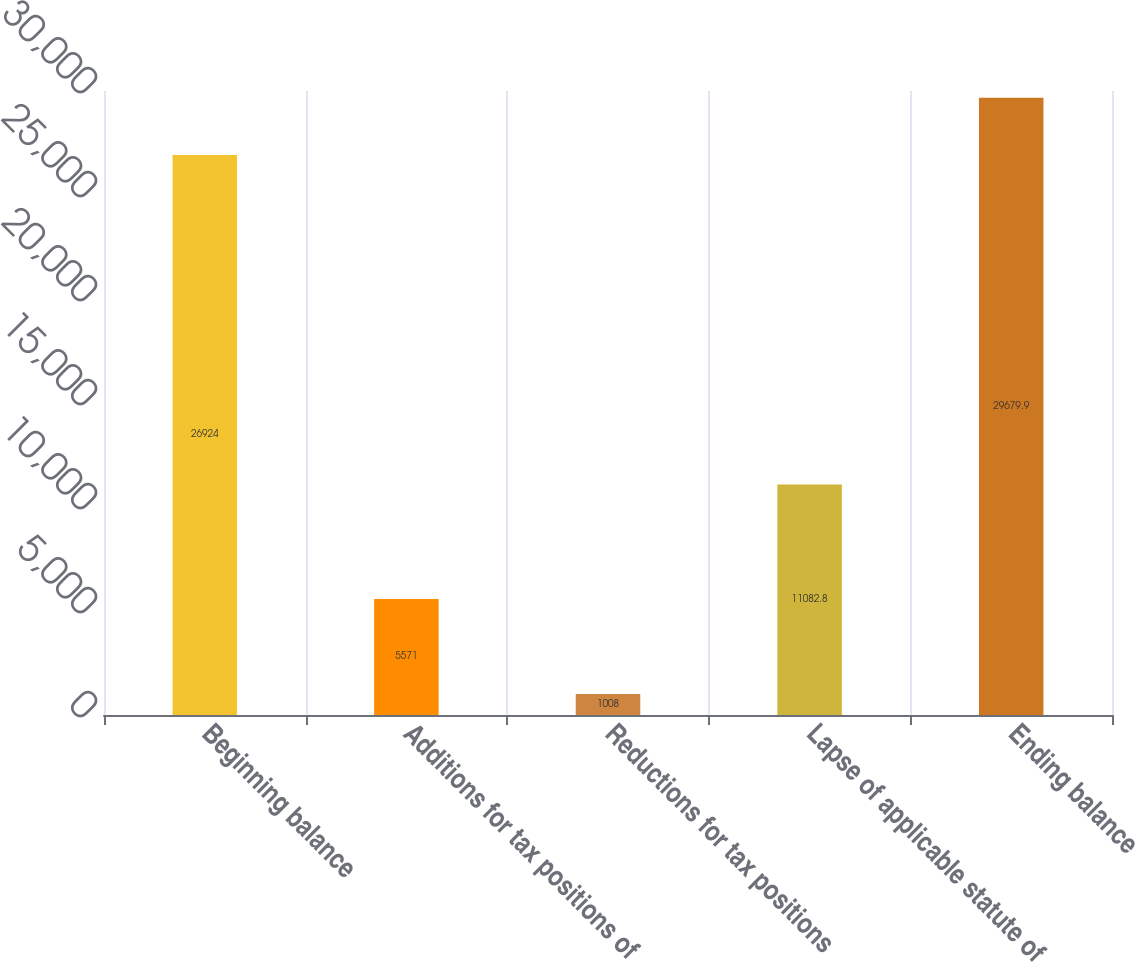Convert chart to OTSL. <chart><loc_0><loc_0><loc_500><loc_500><bar_chart><fcel>Beginning balance<fcel>Additions for tax positions of<fcel>Reductions for tax positions<fcel>Lapse of applicable statute of<fcel>Ending balance<nl><fcel>26924<fcel>5571<fcel>1008<fcel>11082.8<fcel>29679.9<nl></chart> 